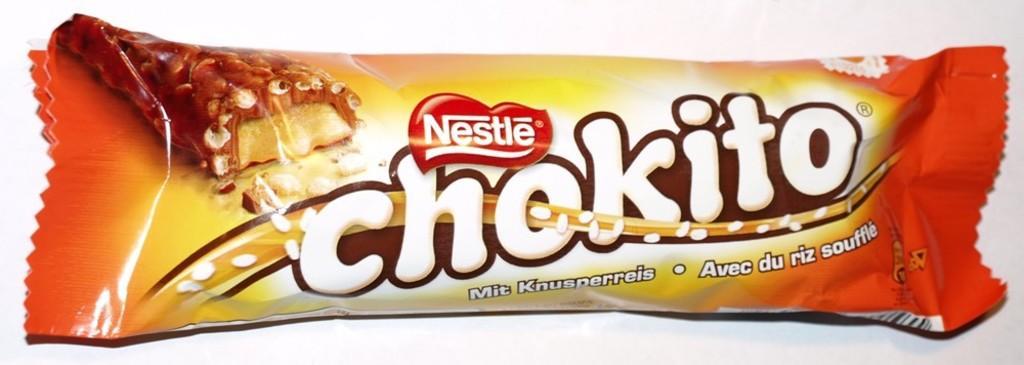How would you summarize this image in a sentence or two? In this image in the center there is one chocolate packet, and on the chocolate packet there is some text. 